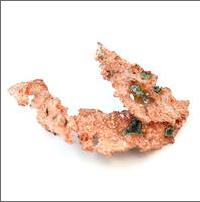Is native copper a mineral? yes why? Properties are used to identify different substances. Minerals have the following properties:
It is a solid.
It is formed in nature.
It is not made by organisms.
It is a pure substance.
It has a fixed crystal structure.
If a substance has all five of these properties, then it is a mineral.
Look closely at the last three properties:
A mineral is not made by organisms.
Organisms make their own body parts. For example, snails and clams make their shells. Because they are made by organisms, body parts cannot be minerals.
Humans are organisms too. So, substances that humans make by hand or in factories cannot be minerals.
A mineral is a pure substance.
A pure substance is made of only one type of matter. All minerals are pure substances.
A mineral has a fixed crystal structure.
The crystal structure of a substance tells you how the atoms or molecules in the substance are arranged. Different types of minerals have different crystal structures, but all minerals have a fixed crystal structure. This means that the atoms or molecules in different pieces of the same type of mineral are always arranged the same way.
 Native copper has all the properties of a mineral. So, native copper is a mineral. 